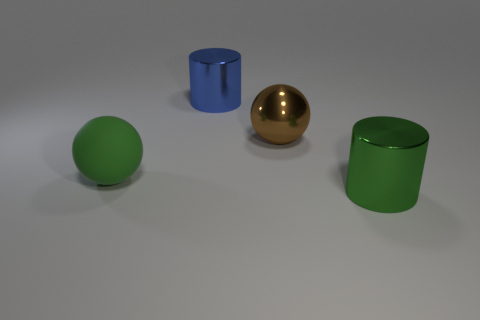There is another shiny object that is the same shape as the large blue metallic object; what color is it?
Offer a terse response. Green. What number of objects are either large brown matte cylinders or green metal cylinders?
Keep it short and to the point. 1. What shape is the brown object that is made of the same material as the blue cylinder?
Make the answer very short. Sphere. How many small things are either green cubes or metallic spheres?
Make the answer very short. 0. What number of other things are there of the same color as the metal ball?
Your answer should be very brief. 0. There is a large blue metal object behind the ball that is to the left of the metal ball; how many spheres are right of it?
Your response must be concise. 1. Is the size of the metallic object in front of the matte sphere the same as the big shiny sphere?
Your response must be concise. Yes. Are there fewer green objects to the right of the brown metallic sphere than green things that are in front of the blue shiny object?
Ensure brevity in your answer.  Yes. Is the big rubber object the same color as the big shiny ball?
Your response must be concise. No. Is the number of balls right of the blue shiny cylinder less than the number of green metal cylinders?
Offer a very short reply. No. 